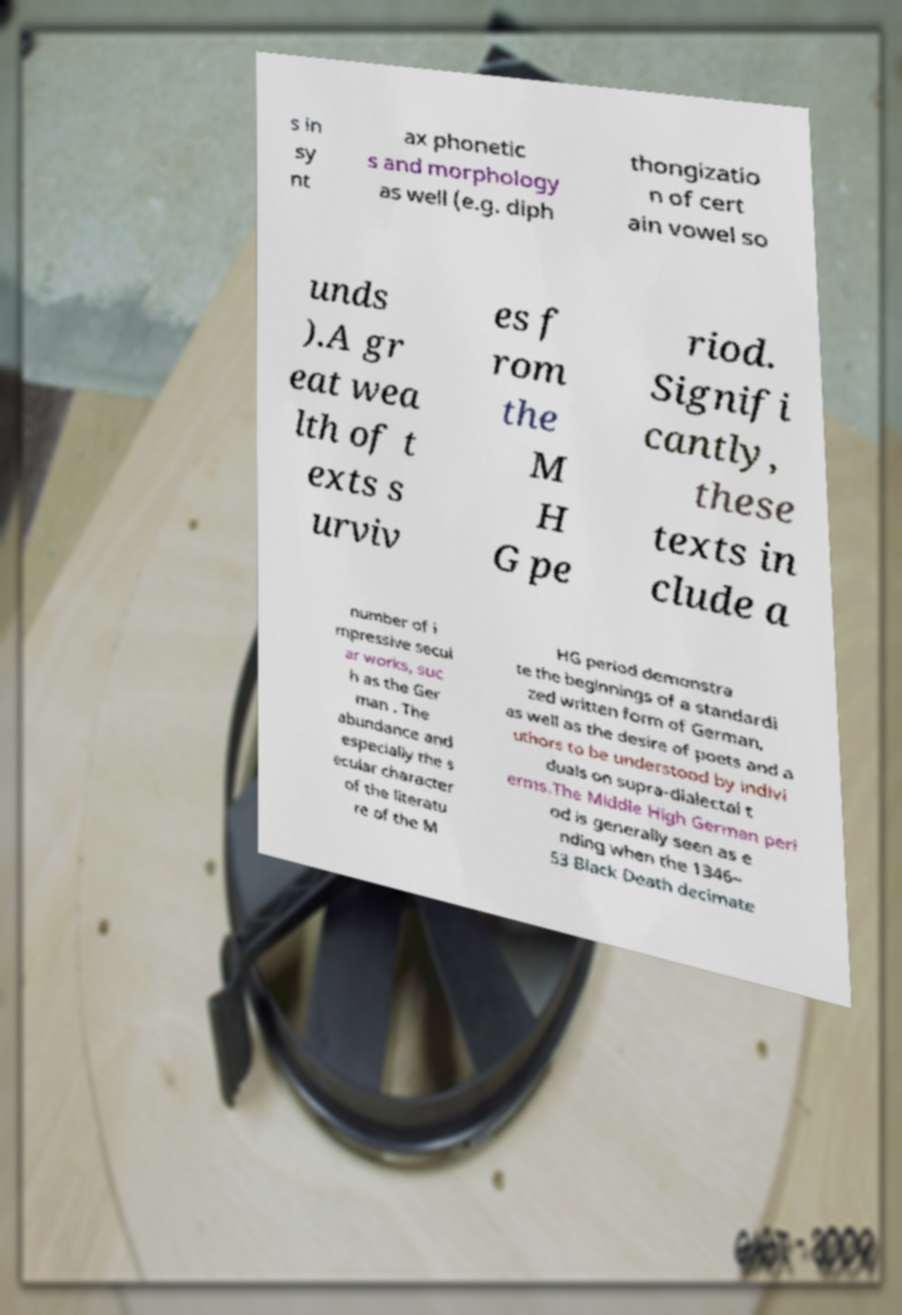Could you assist in decoding the text presented in this image and type it out clearly? s in sy nt ax phonetic s and morphology as well (e.g. diph thongizatio n of cert ain vowel so unds ).A gr eat wea lth of t exts s urviv es f rom the M H G pe riod. Signifi cantly, these texts in clude a number of i mpressive secul ar works, suc h as the Ger man . The abundance and especially the s ecular character of the literatu re of the M HG period demonstra te the beginnings of a standardi zed written form of German, as well as the desire of poets and a uthors to be understood by indivi duals on supra-dialectal t erms.The Middle High German peri od is generally seen as e nding when the 1346– 53 Black Death decimate 